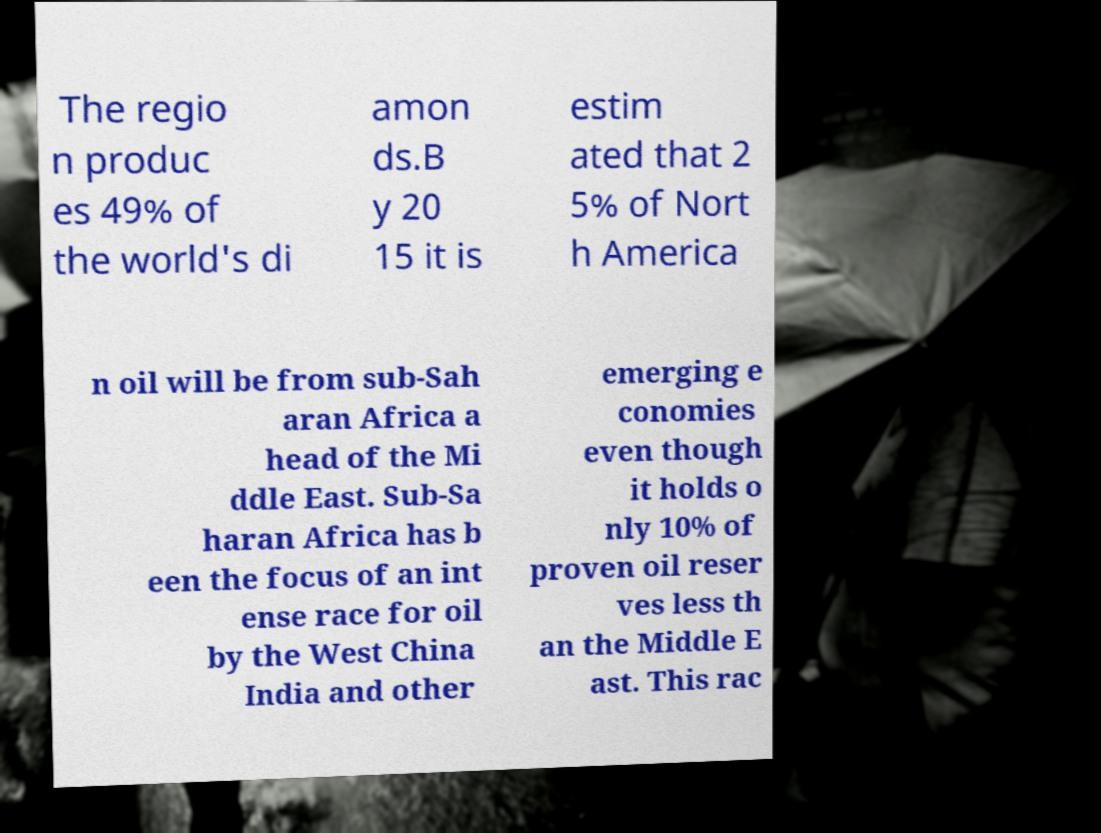There's text embedded in this image that I need extracted. Can you transcribe it verbatim? The regio n produc es 49% of the world's di amon ds.B y 20 15 it is estim ated that 2 5% of Nort h America n oil will be from sub-Sah aran Africa a head of the Mi ddle East. Sub-Sa haran Africa has b een the focus of an int ense race for oil by the West China India and other emerging e conomies even though it holds o nly 10% of proven oil reser ves less th an the Middle E ast. This rac 